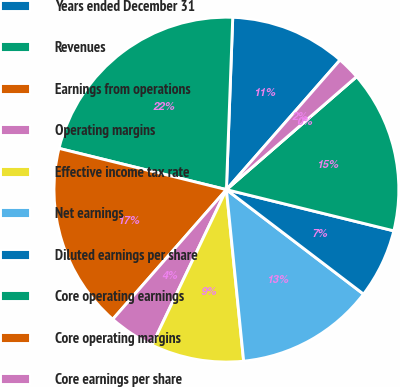<chart> <loc_0><loc_0><loc_500><loc_500><pie_chart><fcel>Years ended December 31<fcel>Revenues<fcel>Earnings from operations<fcel>Operating margins<fcel>Effective income tax rate<fcel>Net earnings<fcel>Diluted earnings per share<fcel>Core operating earnings<fcel>Core operating margins<fcel>Core earnings per share<nl><fcel>10.87%<fcel>21.74%<fcel>17.39%<fcel>4.35%<fcel>8.7%<fcel>13.04%<fcel>6.52%<fcel>15.22%<fcel>0.0%<fcel>2.17%<nl></chart> 